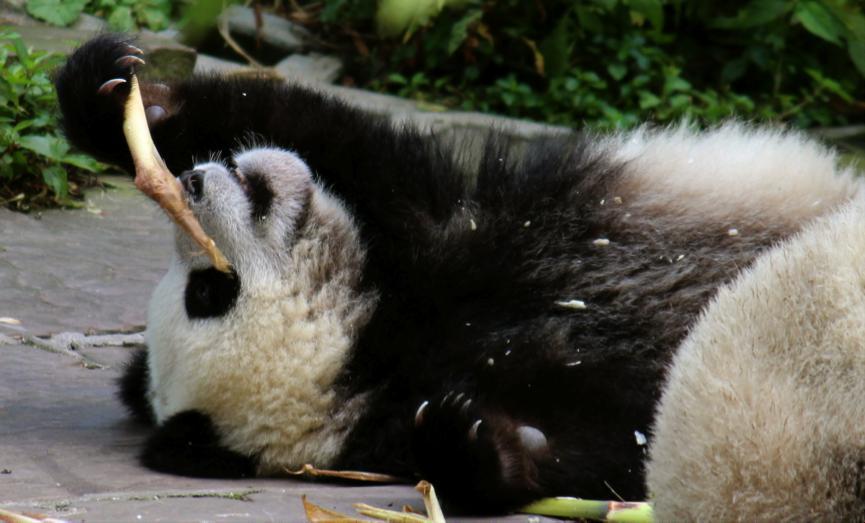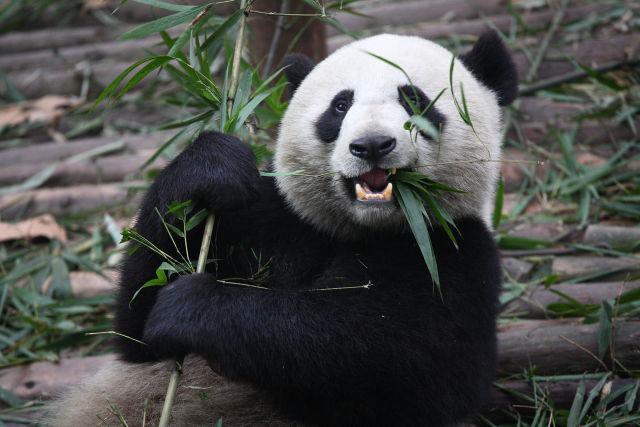The first image is the image on the left, the second image is the image on the right. For the images displayed, is the sentence "One image features one forward-facing panda chewing green leaves, with the paw on the left raised and curled over." factually correct? Answer yes or no. Yes. The first image is the image on the left, the second image is the image on the right. Examine the images to the left and right. Is the description "There are two pandas eating." accurate? Answer yes or no. Yes. 